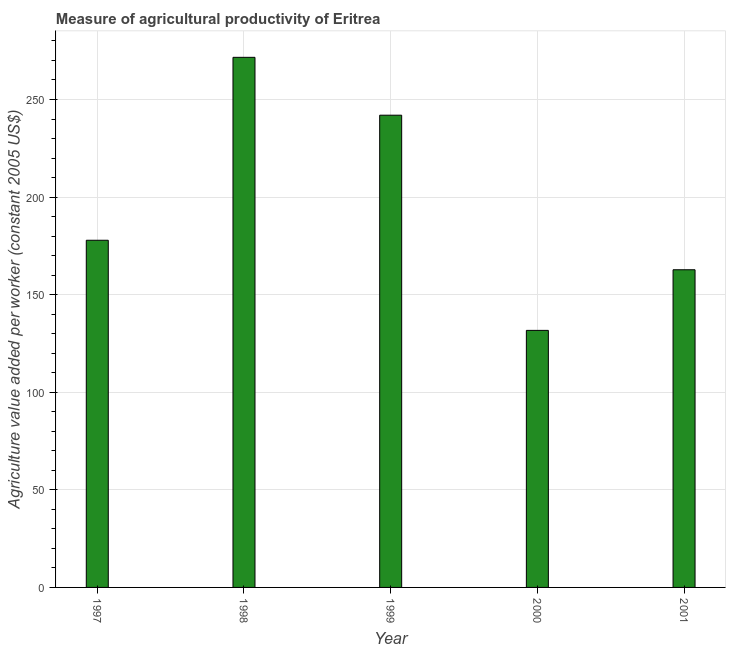Does the graph contain any zero values?
Ensure brevity in your answer.  No. What is the title of the graph?
Give a very brief answer. Measure of agricultural productivity of Eritrea. What is the label or title of the Y-axis?
Make the answer very short. Agriculture value added per worker (constant 2005 US$). What is the agriculture value added per worker in 2001?
Offer a very short reply. 162.77. Across all years, what is the maximum agriculture value added per worker?
Keep it short and to the point. 271.6. Across all years, what is the minimum agriculture value added per worker?
Your response must be concise. 131.7. What is the sum of the agriculture value added per worker?
Offer a very short reply. 985.89. What is the difference between the agriculture value added per worker in 1997 and 1998?
Offer a very short reply. -93.73. What is the average agriculture value added per worker per year?
Provide a succinct answer. 197.18. What is the median agriculture value added per worker?
Provide a succinct answer. 177.87. In how many years, is the agriculture value added per worker greater than 180 US$?
Offer a terse response. 2. Do a majority of the years between 1998 and 2000 (inclusive) have agriculture value added per worker greater than 20 US$?
Provide a short and direct response. Yes. What is the ratio of the agriculture value added per worker in 1998 to that in 1999?
Provide a succinct answer. 1.12. What is the difference between the highest and the second highest agriculture value added per worker?
Provide a succinct answer. 29.64. Is the sum of the agriculture value added per worker in 1997 and 2000 greater than the maximum agriculture value added per worker across all years?
Provide a succinct answer. Yes. What is the difference between the highest and the lowest agriculture value added per worker?
Ensure brevity in your answer.  139.9. How many years are there in the graph?
Provide a short and direct response. 5. Are the values on the major ticks of Y-axis written in scientific E-notation?
Your response must be concise. No. What is the Agriculture value added per worker (constant 2005 US$) in 1997?
Keep it short and to the point. 177.87. What is the Agriculture value added per worker (constant 2005 US$) in 1998?
Ensure brevity in your answer.  271.6. What is the Agriculture value added per worker (constant 2005 US$) in 1999?
Provide a short and direct response. 241.96. What is the Agriculture value added per worker (constant 2005 US$) of 2000?
Your response must be concise. 131.7. What is the Agriculture value added per worker (constant 2005 US$) in 2001?
Provide a succinct answer. 162.77. What is the difference between the Agriculture value added per worker (constant 2005 US$) in 1997 and 1998?
Provide a short and direct response. -93.73. What is the difference between the Agriculture value added per worker (constant 2005 US$) in 1997 and 1999?
Keep it short and to the point. -64.08. What is the difference between the Agriculture value added per worker (constant 2005 US$) in 1997 and 2000?
Your answer should be very brief. 46.18. What is the difference between the Agriculture value added per worker (constant 2005 US$) in 1997 and 2001?
Your response must be concise. 15.11. What is the difference between the Agriculture value added per worker (constant 2005 US$) in 1998 and 1999?
Offer a very short reply. 29.65. What is the difference between the Agriculture value added per worker (constant 2005 US$) in 1998 and 2000?
Make the answer very short. 139.9. What is the difference between the Agriculture value added per worker (constant 2005 US$) in 1998 and 2001?
Ensure brevity in your answer.  108.84. What is the difference between the Agriculture value added per worker (constant 2005 US$) in 1999 and 2000?
Offer a terse response. 110.26. What is the difference between the Agriculture value added per worker (constant 2005 US$) in 1999 and 2001?
Provide a short and direct response. 79.19. What is the difference between the Agriculture value added per worker (constant 2005 US$) in 2000 and 2001?
Ensure brevity in your answer.  -31.07. What is the ratio of the Agriculture value added per worker (constant 2005 US$) in 1997 to that in 1998?
Make the answer very short. 0.66. What is the ratio of the Agriculture value added per worker (constant 2005 US$) in 1997 to that in 1999?
Give a very brief answer. 0.73. What is the ratio of the Agriculture value added per worker (constant 2005 US$) in 1997 to that in 2000?
Keep it short and to the point. 1.35. What is the ratio of the Agriculture value added per worker (constant 2005 US$) in 1997 to that in 2001?
Your answer should be compact. 1.09. What is the ratio of the Agriculture value added per worker (constant 2005 US$) in 1998 to that in 1999?
Your answer should be compact. 1.12. What is the ratio of the Agriculture value added per worker (constant 2005 US$) in 1998 to that in 2000?
Provide a short and direct response. 2.06. What is the ratio of the Agriculture value added per worker (constant 2005 US$) in 1998 to that in 2001?
Offer a very short reply. 1.67. What is the ratio of the Agriculture value added per worker (constant 2005 US$) in 1999 to that in 2000?
Offer a very short reply. 1.84. What is the ratio of the Agriculture value added per worker (constant 2005 US$) in 1999 to that in 2001?
Give a very brief answer. 1.49. What is the ratio of the Agriculture value added per worker (constant 2005 US$) in 2000 to that in 2001?
Offer a very short reply. 0.81. 